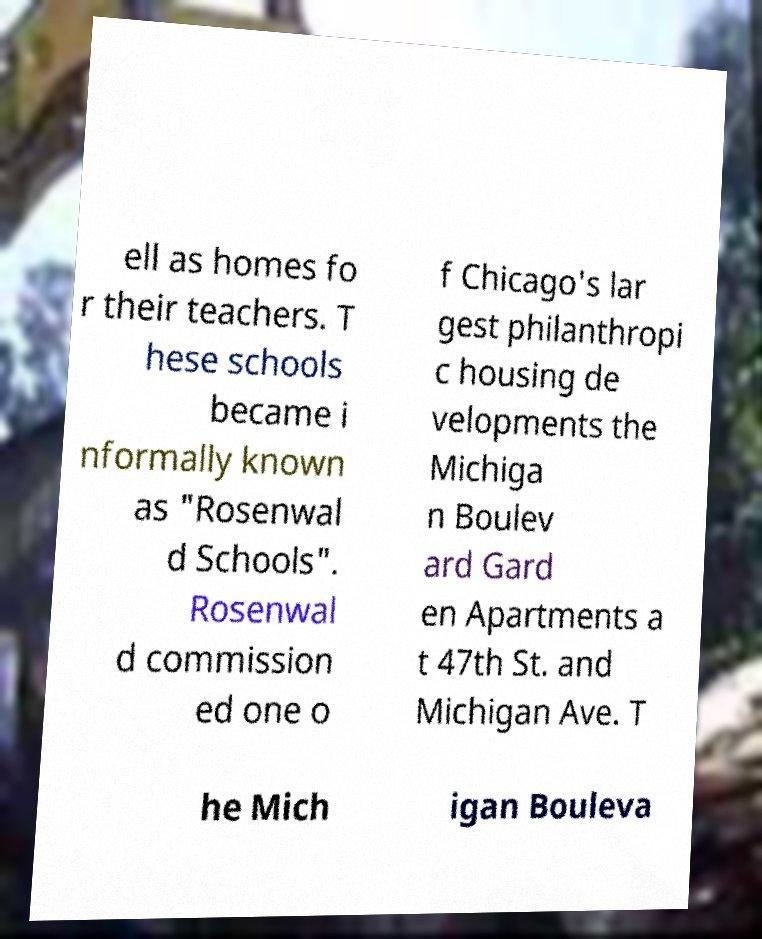I need the written content from this picture converted into text. Can you do that? ell as homes fo r their teachers. T hese schools became i nformally known as "Rosenwal d Schools". Rosenwal d commission ed one o f Chicago's lar gest philanthropi c housing de velopments the Michiga n Boulev ard Gard en Apartments a t 47th St. and Michigan Ave. T he Mich igan Bouleva 